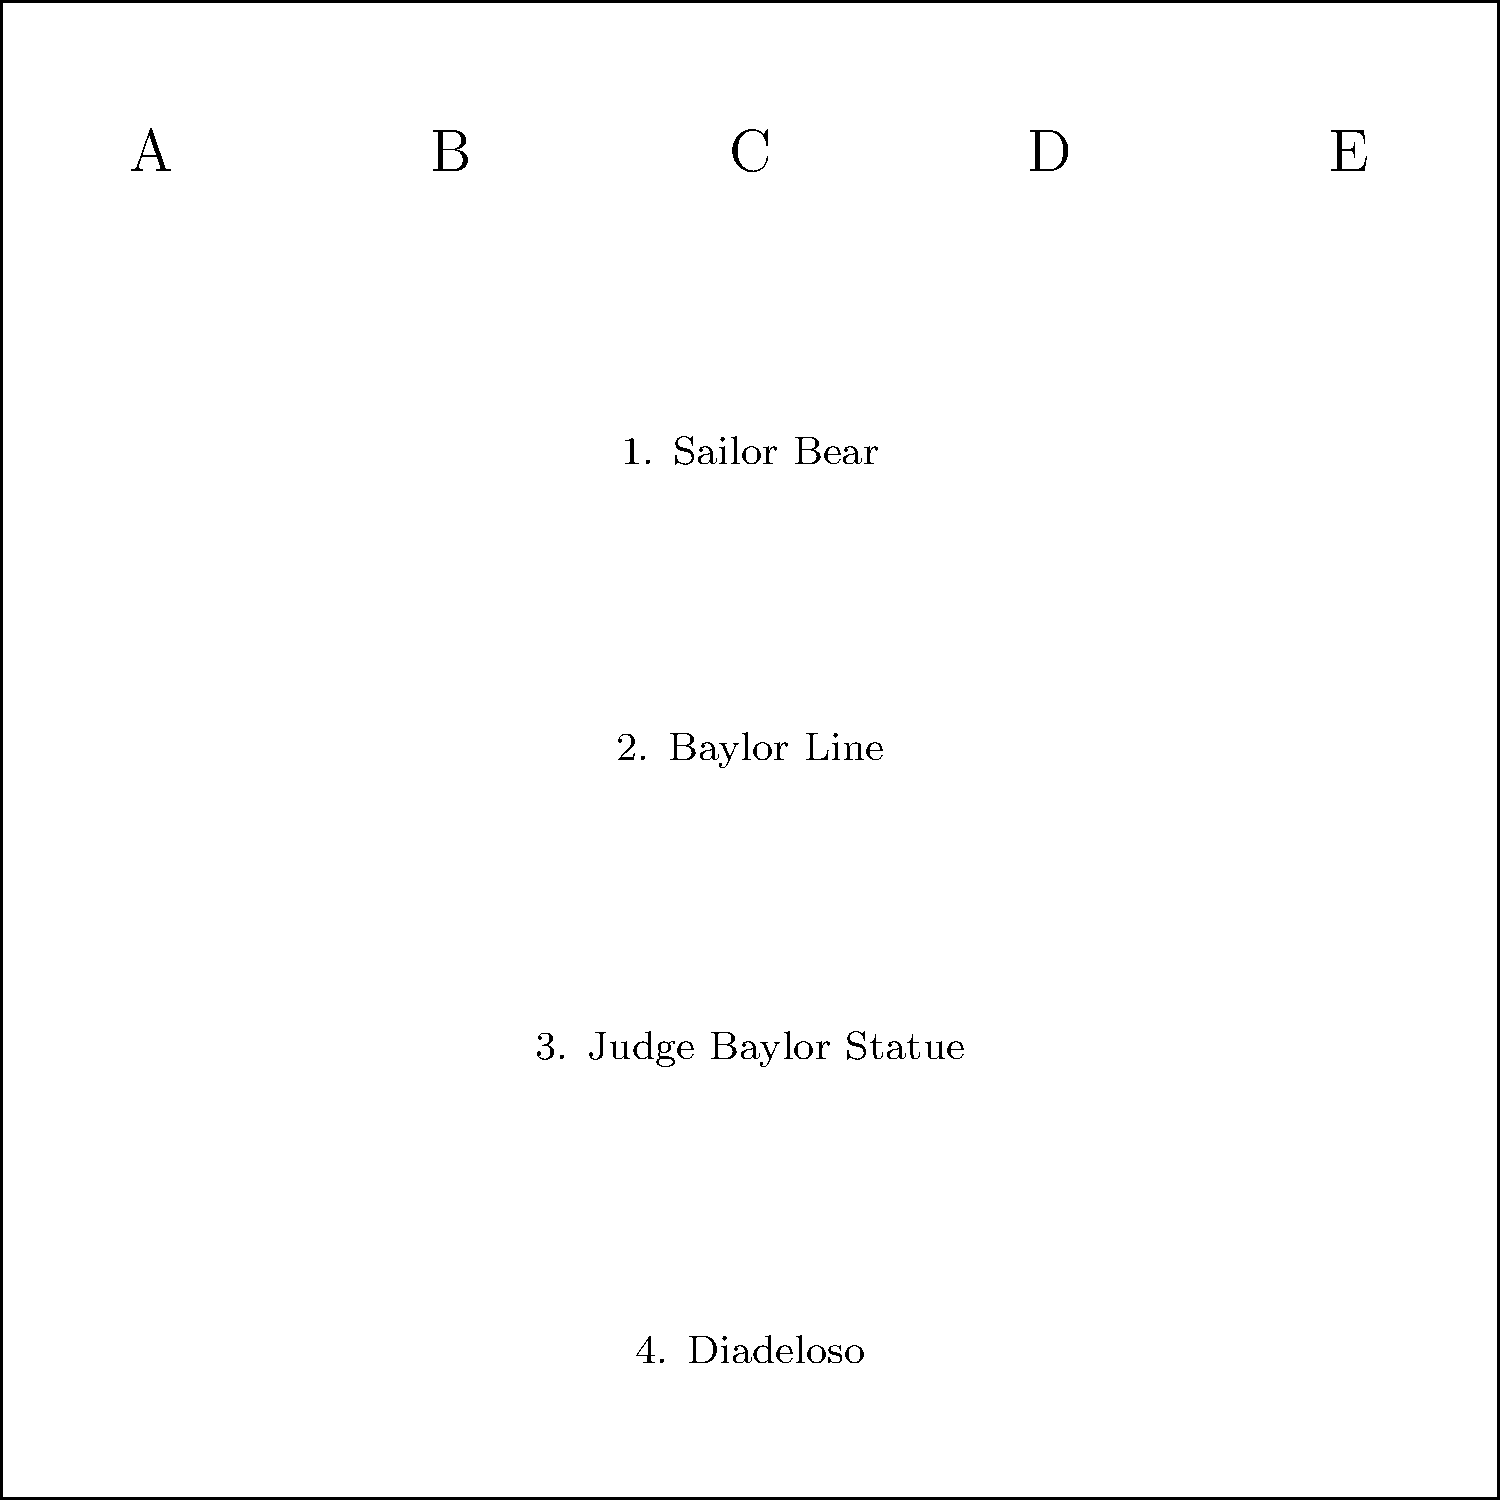Match the Baylor University tradition symbols (A-E) to their corresponding events or meanings (1-4):

A. Bear silhouette
B. Gold line
C. Human figure statue
D. Sun symbol
E. Green ring

1. Sailor Bear
2. Baylor Line
3. Judge Baylor Statue
4. Diadeloso To match the symbols with their corresponding events or meanings, let's go through each one:

1. Sailor Bear: This is represented by the bear silhouette (A). The Sailor Bear is a classic Baylor mascot design featuring a bear in a sailor suit.

2. Baylor Line: This is represented by the gold line (B). The Baylor Line is a longstanding tradition where freshmen wear gold jerseys and form a human tunnel for the football team to run through before home games.

3. Judge Baylor Statue: This is represented by the human figure statue (C). There is a prominent statue of Judge R.E.B. Baylor, the university's namesake, on campus.

4. Diadeloso: This is represented by the sun symbol (D). Diadeloso, or "Day of the Bear," is an annual spring holiday at Baylor featuring outdoor activities and no classes.

5. The green ring (E) doesn't correspond to any of the given events or meanings. It might represent other Baylor traditions or symbols not listed here.
Answer: A1, B2, C3, D4 